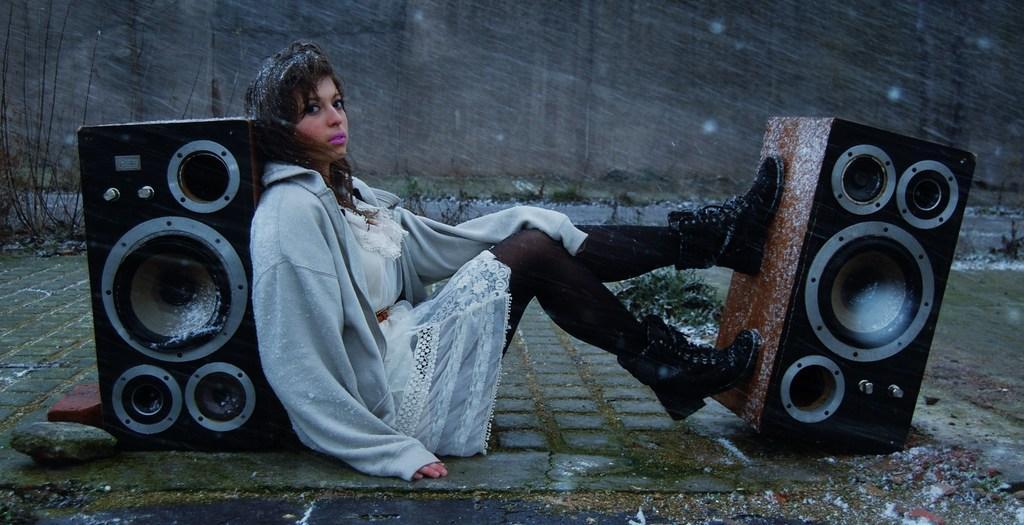In one or two sentences, can you explain what this image depicts? In the image there is a girl sitting on the land, there are two speakers on either side of her, she wore sweat shirt and cap, back of her there is wall. 